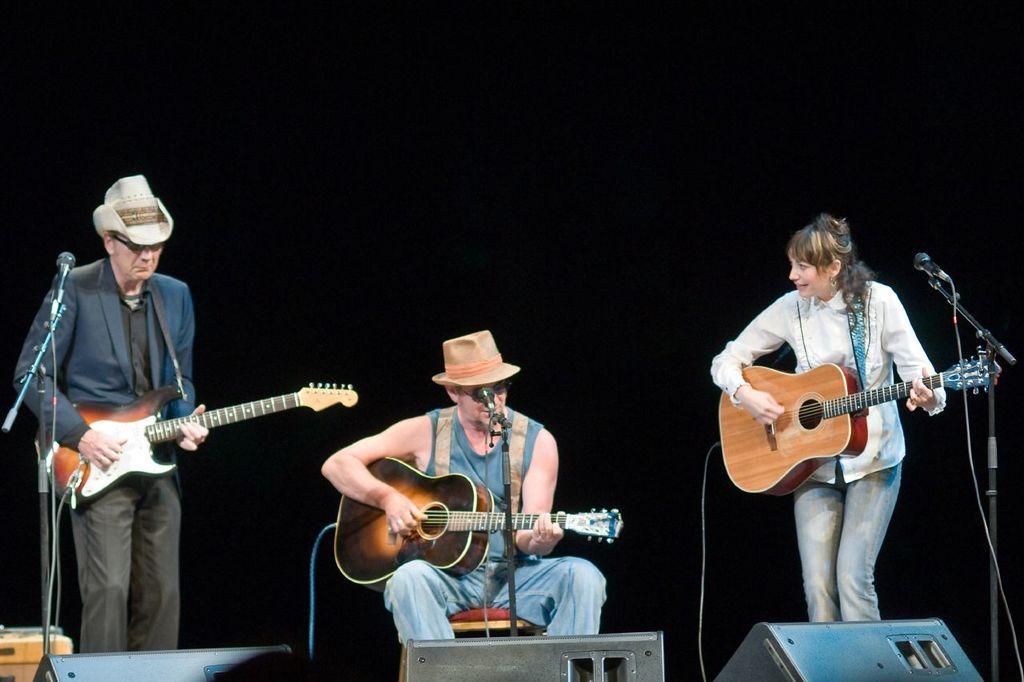Can you describe this image briefly? In this picture three people are playing guitar with a mic placed in front of them. The image is clicked in a musical concert. There are also sounds boxes placed in front of them. 